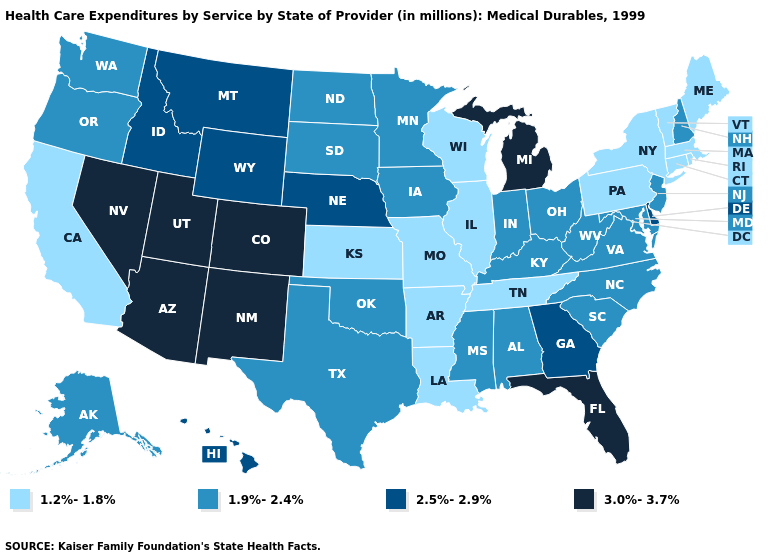How many symbols are there in the legend?
Short answer required. 4. What is the value of Arizona?
Be succinct. 3.0%-3.7%. Among the states that border Virginia , which have the highest value?
Answer briefly. Kentucky, Maryland, North Carolina, West Virginia. What is the value of Wisconsin?
Short answer required. 1.2%-1.8%. What is the lowest value in states that border Texas?
Concise answer only. 1.2%-1.8%. Does Virginia have a lower value than Arizona?
Answer briefly. Yes. Does the map have missing data?
Write a very short answer. No. Does Tennessee have the highest value in the South?
Quick response, please. No. What is the value of Arkansas?
Concise answer only. 1.2%-1.8%. What is the value of Florida?
Answer briefly. 3.0%-3.7%. Which states hav the highest value in the MidWest?
Concise answer only. Michigan. What is the value of Oregon?
Short answer required. 1.9%-2.4%. What is the value of Alaska?
Be succinct. 1.9%-2.4%. Name the states that have a value in the range 2.5%-2.9%?
Answer briefly. Delaware, Georgia, Hawaii, Idaho, Montana, Nebraska, Wyoming. What is the highest value in the USA?
Quick response, please. 3.0%-3.7%. 